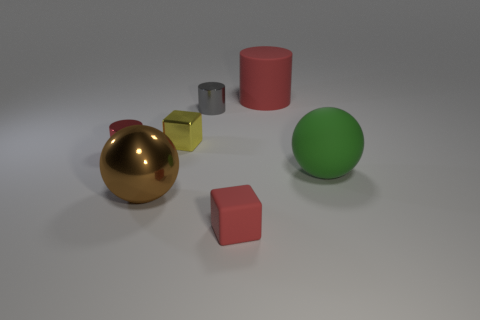How many other things are there of the same size as the yellow block?
Ensure brevity in your answer.  3. What is the color of the tiny matte cube?
Provide a short and direct response. Red. What number of shiny things are either green objects or yellow things?
Offer a terse response. 1. Is there any other thing that is the same material as the tiny yellow thing?
Ensure brevity in your answer.  Yes. How big is the red cylinder right of the ball that is left of the large sphere right of the red matte cylinder?
Offer a terse response. Large. What size is the rubber object that is behind the brown shiny object and in front of the gray cylinder?
Your answer should be compact. Large. Is the color of the rubber thing left of the large matte cylinder the same as the small cylinder that is in front of the yellow thing?
Make the answer very short. Yes. What number of tiny objects are to the left of the metal block?
Provide a short and direct response. 1. There is a small cylinder behind the tiny shiny object that is to the left of the big brown metal thing; is there a tiny cylinder that is in front of it?
Your answer should be compact. Yes. What number of gray cylinders have the same size as the yellow object?
Your answer should be very brief. 1. 